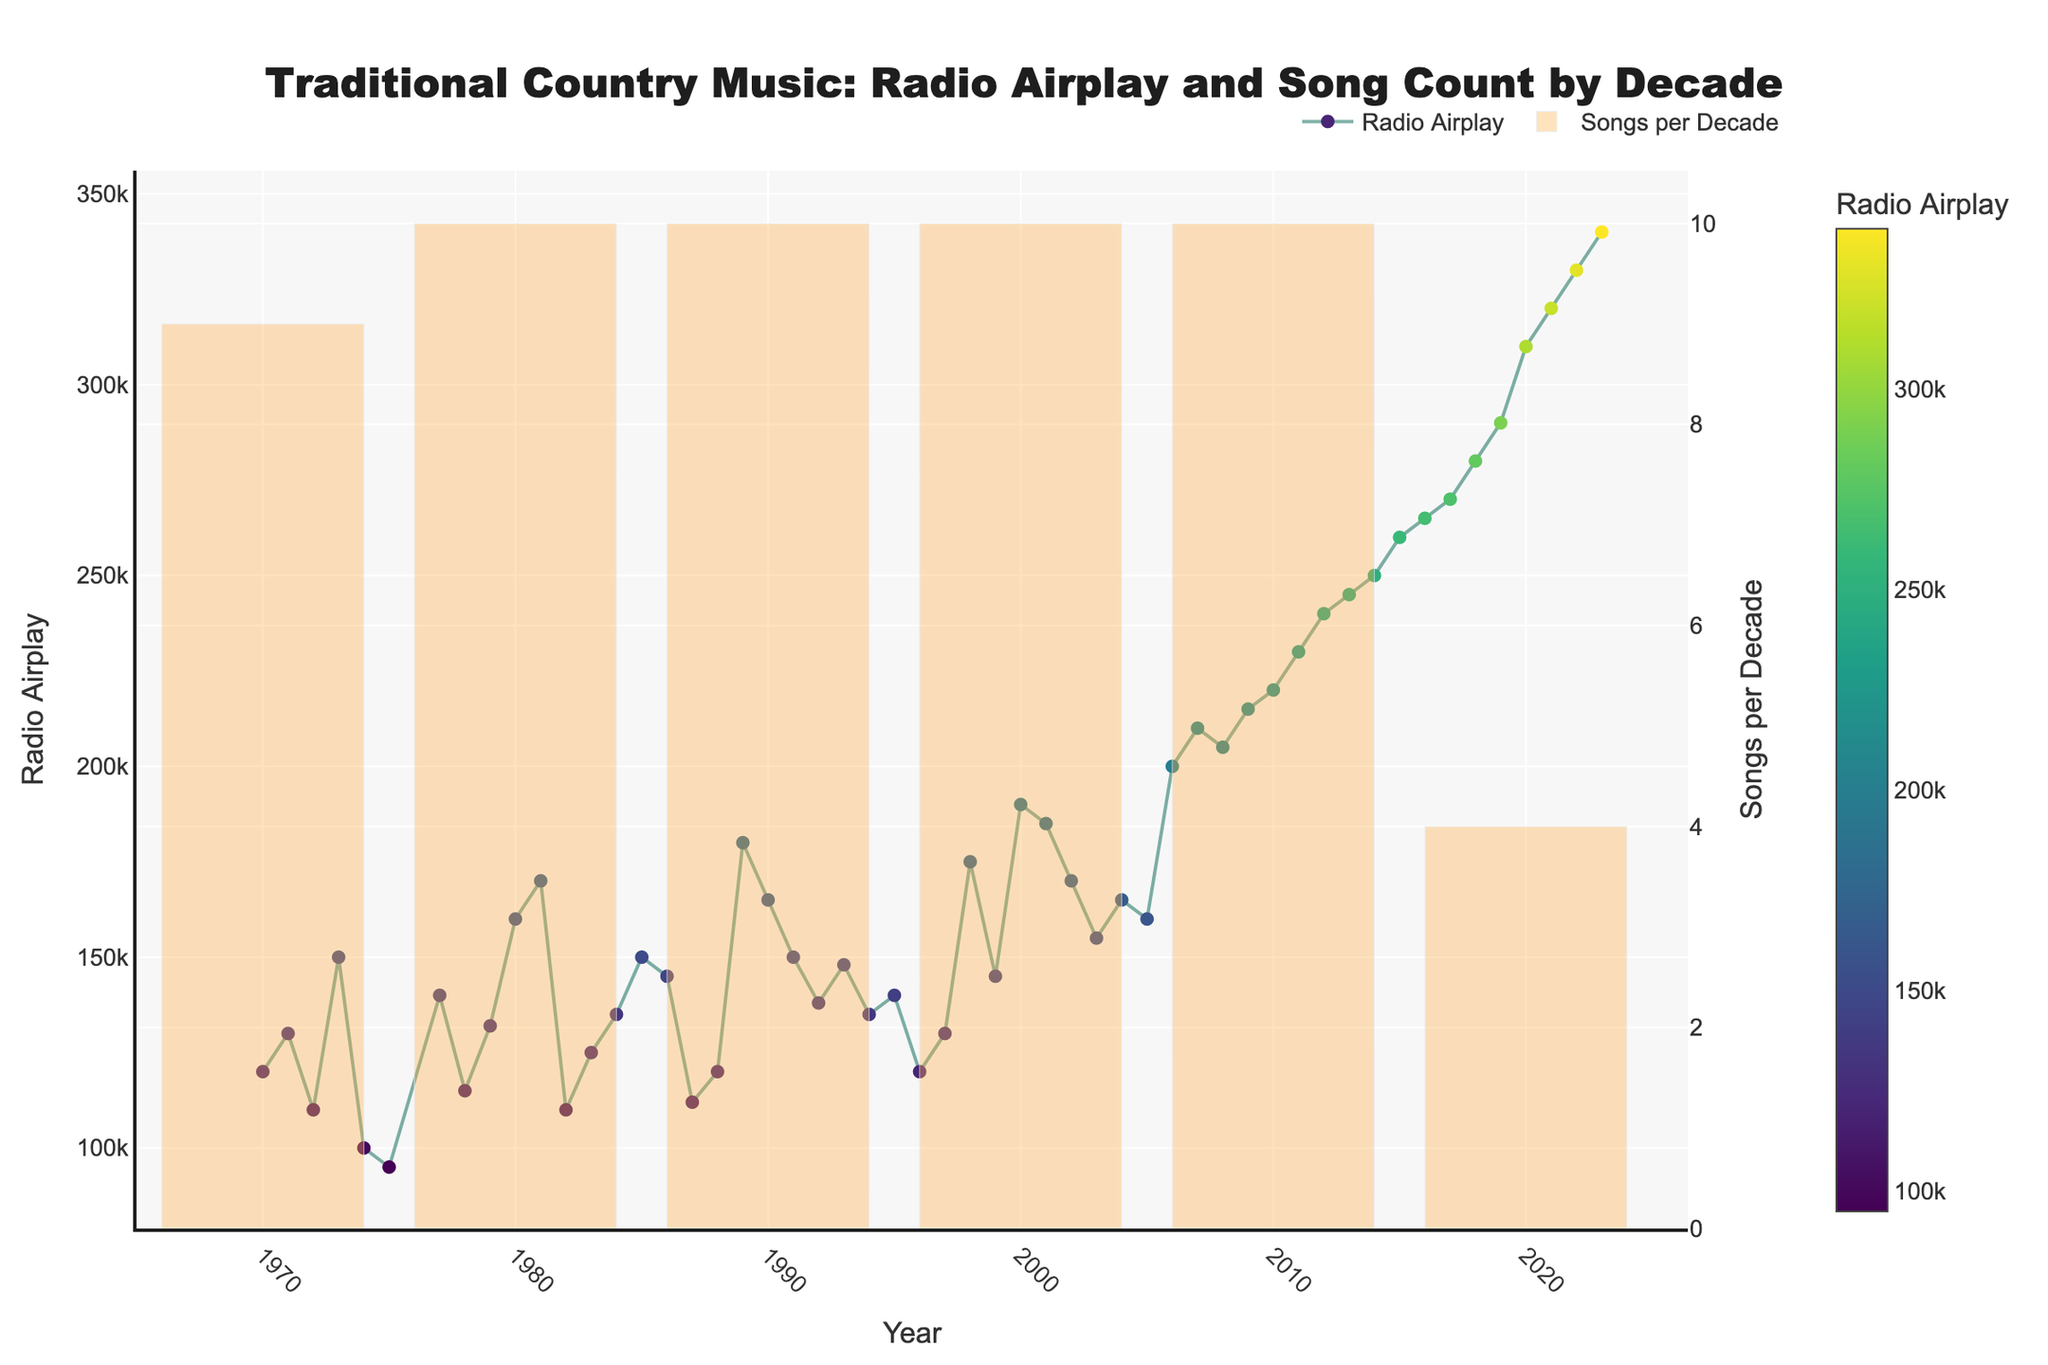What is the title of the plot? The title is displayed at the top center of the figure. Reading it directly gives us: "Traditional Country Music: Radio Airplay and Song Count by Decade".
Answer: Traditional Country Music: Radio Airplay and Song Count by Decade What is the y-axis label for the scatter plot? The scatter plot's y-axis, located on the left side, is labeled "Radio Airplay".
Answer: Radio Airplay Which artist has the highest radio airplay in the plot? To determine this, look for the highest data point on the scatter plot. The highest point corresponds to the year 2023 and belongs to Zach Bryan's "Something in the Orange" with 340,000 plays.
Answer: Zach Bryan How many songs were released in the decade starting in 1990? Identify the bar corresponding to the 1990 decade on the secondary y-axis. There were 10 songs released during that decade.
Answer: 10 Which decade saw the highest number of songs released? By comparing the height of the bars, the decade starting in 2010 has the highest number, indicating it had the most songs released.
Answer: The 2010s What is the trend in radio airplay over the years? Observing the scatter plot, there is a noticeable increasing trend in radio airplay from 1970 to the present.
Answer: Increasing Which song had notably higher radio airplay than others in the early 2000s? Examining the scatter plot around the early 2000s, "Jesus Take the Wheel" by Carrie Underwood in 2006 stands out with 200,000 plays.
Answer: Jesus Take the Wheel What's the difference in radio airplay between 'Coal Miner's Daughter' (1971) and 'Something in the Orange' (2023)? Subtract the radio airplay for "Coal Miner's Daughter" (130,000) from that of "Something in the Orange" (340,000): 340,000 - 130,000 = 210,000.
Answer: 210,000 How did radio airplay for traditional country songs change between 1970 and 2020? Comparing the radio airplay points on the scatter plot, airplay increased from 120,000 in 1970 to 310,000 in 2020.
Answer: Increased from 120,000 to 310,000 